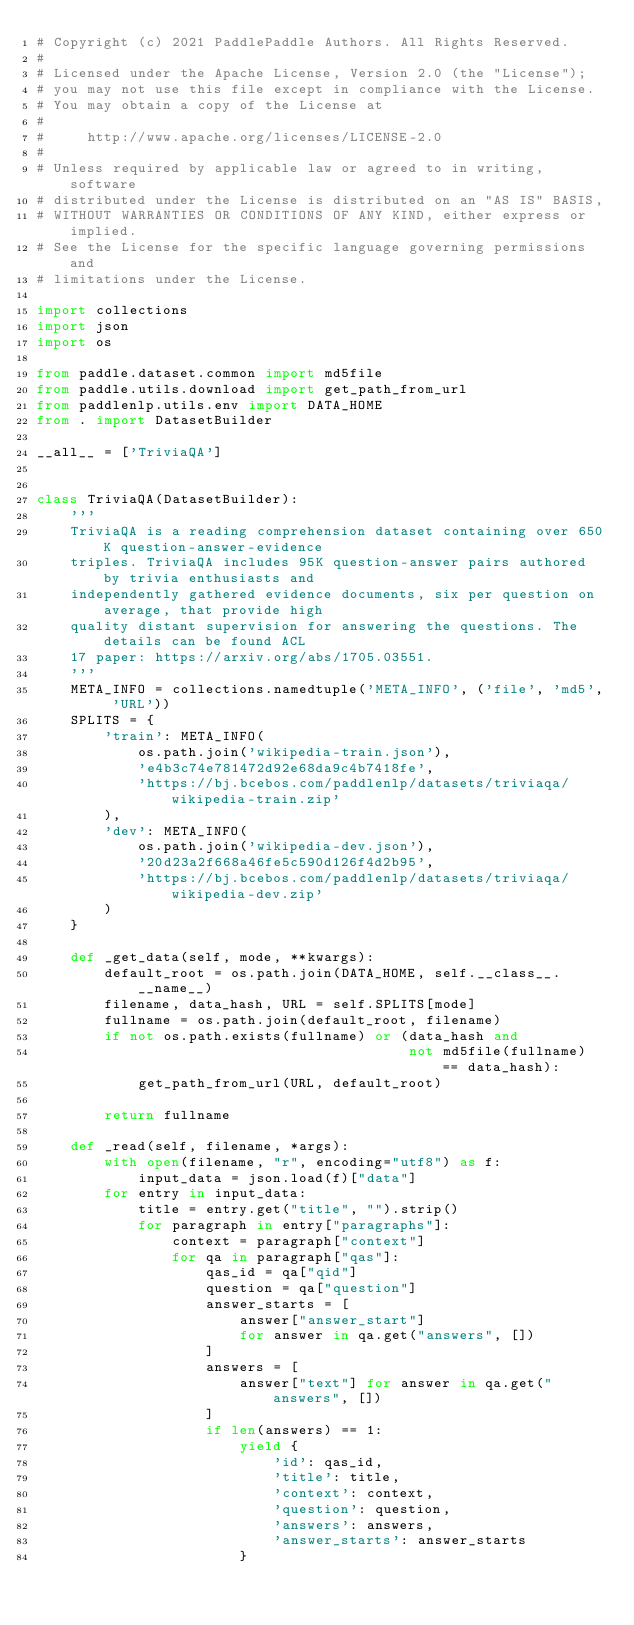<code> <loc_0><loc_0><loc_500><loc_500><_Python_># Copyright (c) 2021 PaddlePaddle Authors. All Rights Reserved.
#
# Licensed under the Apache License, Version 2.0 (the "License");
# you may not use this file except in compliance with the License.
# You may obtain a copy of the License at
#
#     http://www.apache.org/licenses/LICENSE-2.0
#
# Unless required by applicable law or agreed to in writing, software
# distributed under the License is distributed on an "AS IS" BASIS,
# WITHOUT WARRANTIES OR CONDITIONS OF ANY KIND, either express or implied.
# See the License for the specific language governing permissions and
# limitations under the License.

import collections
import json
import os

from paddle.dataset.common import md5file
from paddle.utils.download import get_path_from_url
from paddlenlp.utils.env import DATA_HOME
from . import DatasetBuilder

__all__ = ['TriviaQA']


class TriviaQA(DatasetBuilder):
    '''
    TriviaQA is a reading comprehension dataset containing over 650K question-answer-evidence 
    triples. TriviaQA includes 95K question-answer pairs authored by trivia enthusiasts and 
    independently gathered evidence documents, six per question on average, that provide high 
    quality distant supervision for answering the questions. The details can be found ACL 
    17 paper: https://arxiv.org/abs/1705.03551.
    '''
    META_INFO = collections.namedtuple('META_INFO', ('file', 'md5', 'URL'))
    SPLITS = {
        'train': META_INFO(
            os.path.join('wikipedia-train.json'),
            'e4b3c74e781472d92e68da9c4b7418fe',
            'https://bj.bcebos.com/paddlenlp/datasets/triviaqa/wikipedia-train.zip'
        ),
        'dev': META_INFO(
            os.path.join('wikipedia-dev.json'),
            '20d23a2f668a46fe5c590d126f4d2b95',
            'https://bj.bcebos.com/paddlenlp/datasets/triviaqa/wikipedia-dev.zip'
        )
    }

    def _get_data(self, mode, **kwargs):
        default_root = os.path.join(DATA_HOME, self.__class__.__name__)
        filename, data_hash, URL = self.SPLITS[mode]
        fullname = os.path.join(default_root, filename)
        if not os.path.exists(fullname) or (data_hash and
                                            not md5file(fullname) == data_hash):
            get_path_from_url(URL, default_root)

        return fullname

    def _read(self, filename, *args):
        with open(filename, "r", encoding="utf8") as f:
            input_data = json.load(f)["data"]
        for entry in input_data:
            title = entry.get("title", "").strip()
            for paragraph in entry["paragraphs"]:
                context = paragraph["context"]
                for qa in paragraph["qas"]:
                    qas_id = qa["qid"]
                    question = qa["question"]
                    answer_starts = [
                        answer["answer_start"]
                        for answer in qa.get("answers", [])
                    ]
                    answers = [
                        answer["text"] for answer in qa.get("answers", [])
                    ]
                    if len(answers) == 1:
                        yield {
                            'id': qas_id,
                            'title': title,
                            'context': context,
                            'question': question,
                            'answers': answers,
                            'answer_starts': answer_starts
                        }
</code> 